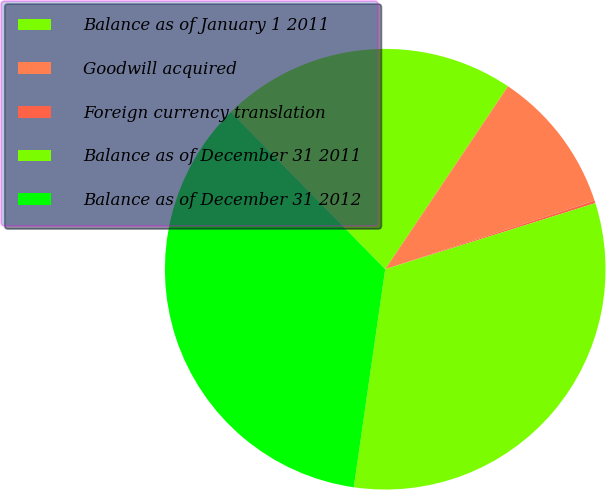Convert chart to OTSL. <chart><loc_0><loc_0><loc_500><loc_500><pie_chart><fcel>Balance as of January 1 2011<fcel>Goodwill acquired<fcel>Foreign currency translation<fcel>Balance as of December 31 2011<fcel>Balance as of December 31 2012<nl><fcel>21.77%<fcel>10.55%<fcel>0.19%<fcel>32.13%<fcel>35.36%<nl></chart> 